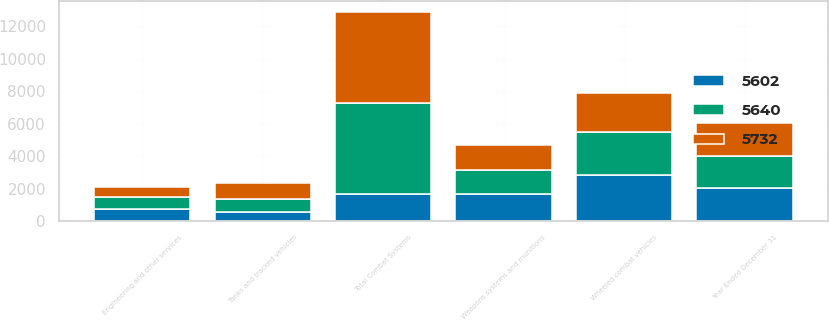Convert chart. <chart><loc_0><loc_0><loc_500><loc_500><stacked_bar_chart><ecel><fcel>Year Ended December 31<fcel>Wheeled combat vehicles<fcel>Weapons systems and munitions<fcel>Tanks and tracked vehicles<fcel>Engineering and other services<fcel>Total Combat Systems<nl><fcel>5732<fcel>2016<fcel>2446<fcel>1533<fcel>987<fcel>636<fcel>5602<nl><fcel>5640<fcel>2015<fcel>2599<fcel>1496<fcel>816<fcel>729<fcel>5640<nl><fcel>5602<fcel>2014<fcel>2852<fcel>1635<fcel>526<fcel>719<fcel>1635<nl></chart> 